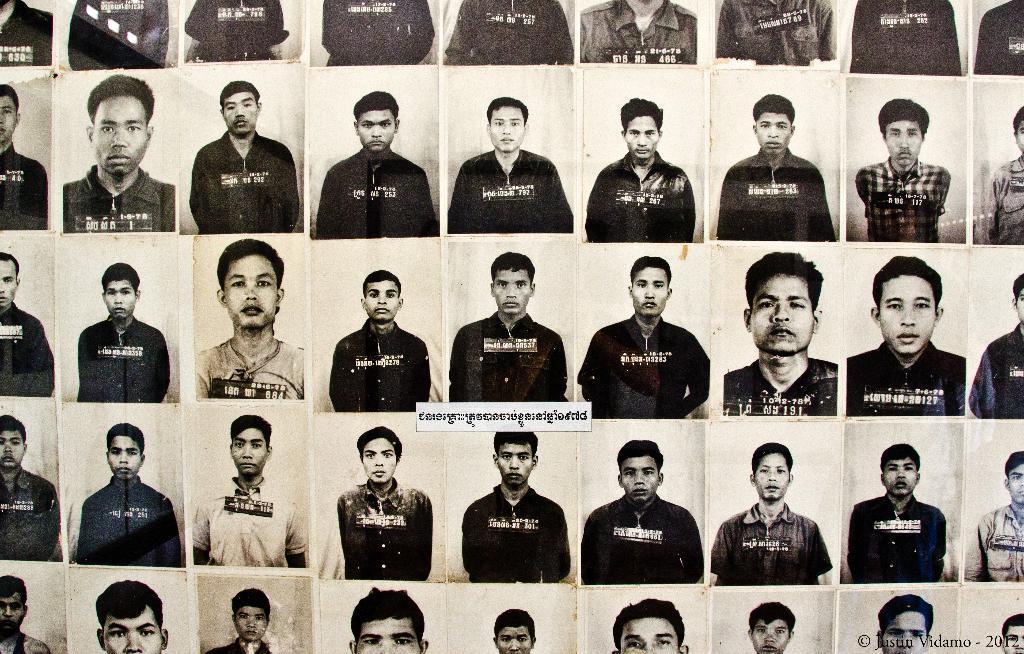Can you describe this image briefly? In this image I see the passport size photos of people and I see the watermark over here. 